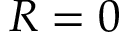<formula> <loc_0><loc_0><loc_500><loc_500>R = 0</formula> 